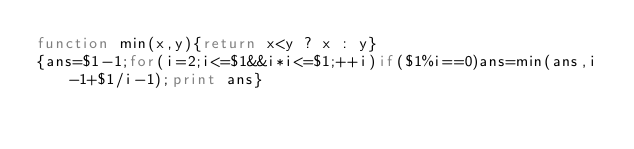Convert code to text. <code><loc_0><loc_0><loc_500><loc_500><_Awk_>function min(x,y){return x<y ? x : y}
{ans=$1-1;for(i=2;i<=$1&&i*i<=$1;++i)if($1%i==0)ans=min(ans,i-1+$1/i-1);print ans}</code> 